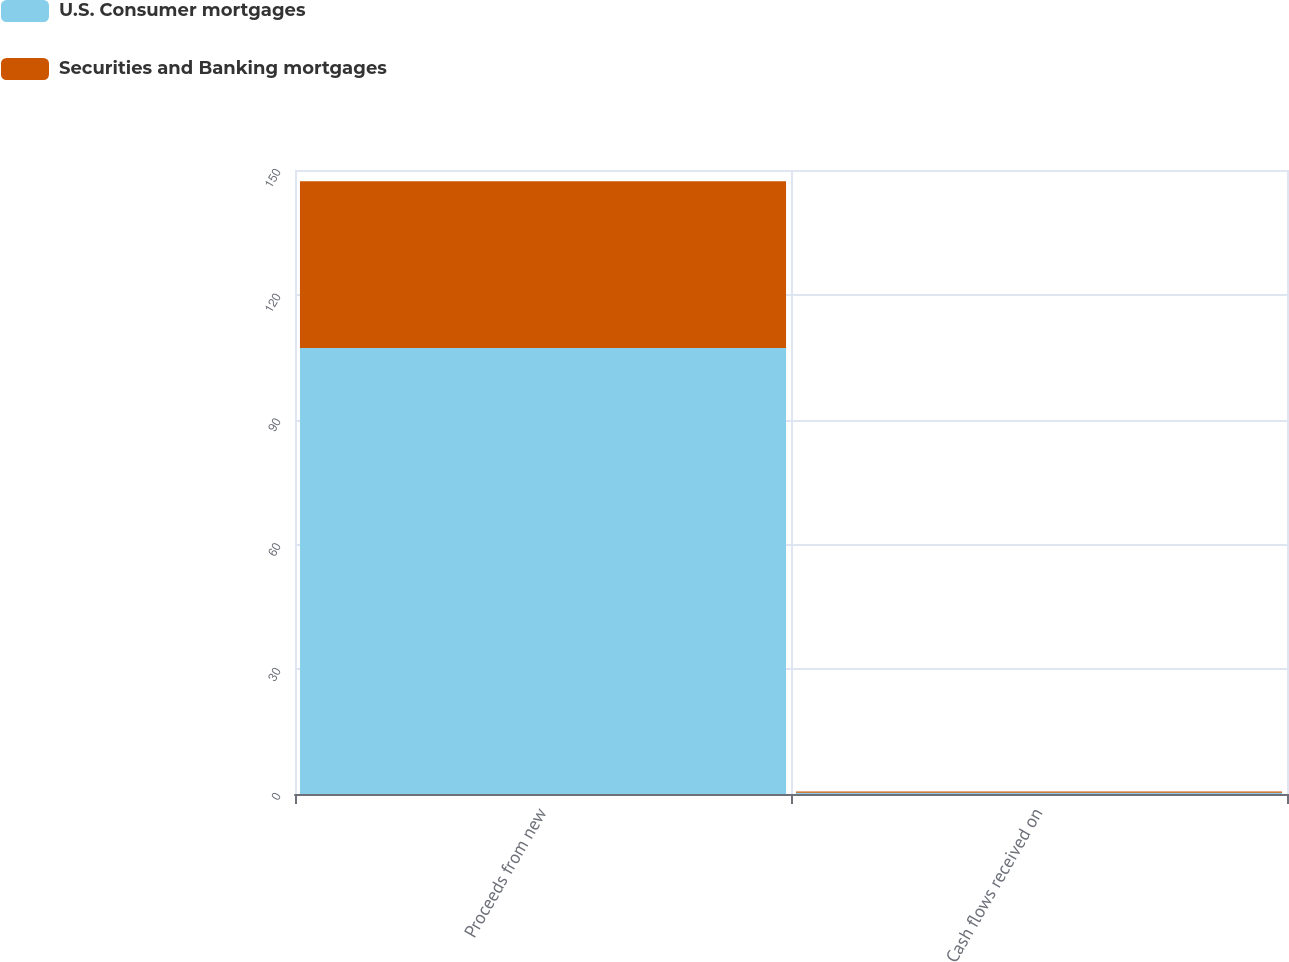Convert chart to OTSL. <chart><loc_0><loc_0><loc_500><loc_500><stacked_bar_chart><ecel><fcel>Proceeds from new<fcel>Cash flows received on<nl><fcel>U.S. Consumer mortgages<fcel>107.2<fcel>0.3<nl><fcel>Securities and Banking mortgages<fcel>40.1<fcel>0.3<nl></chart> 